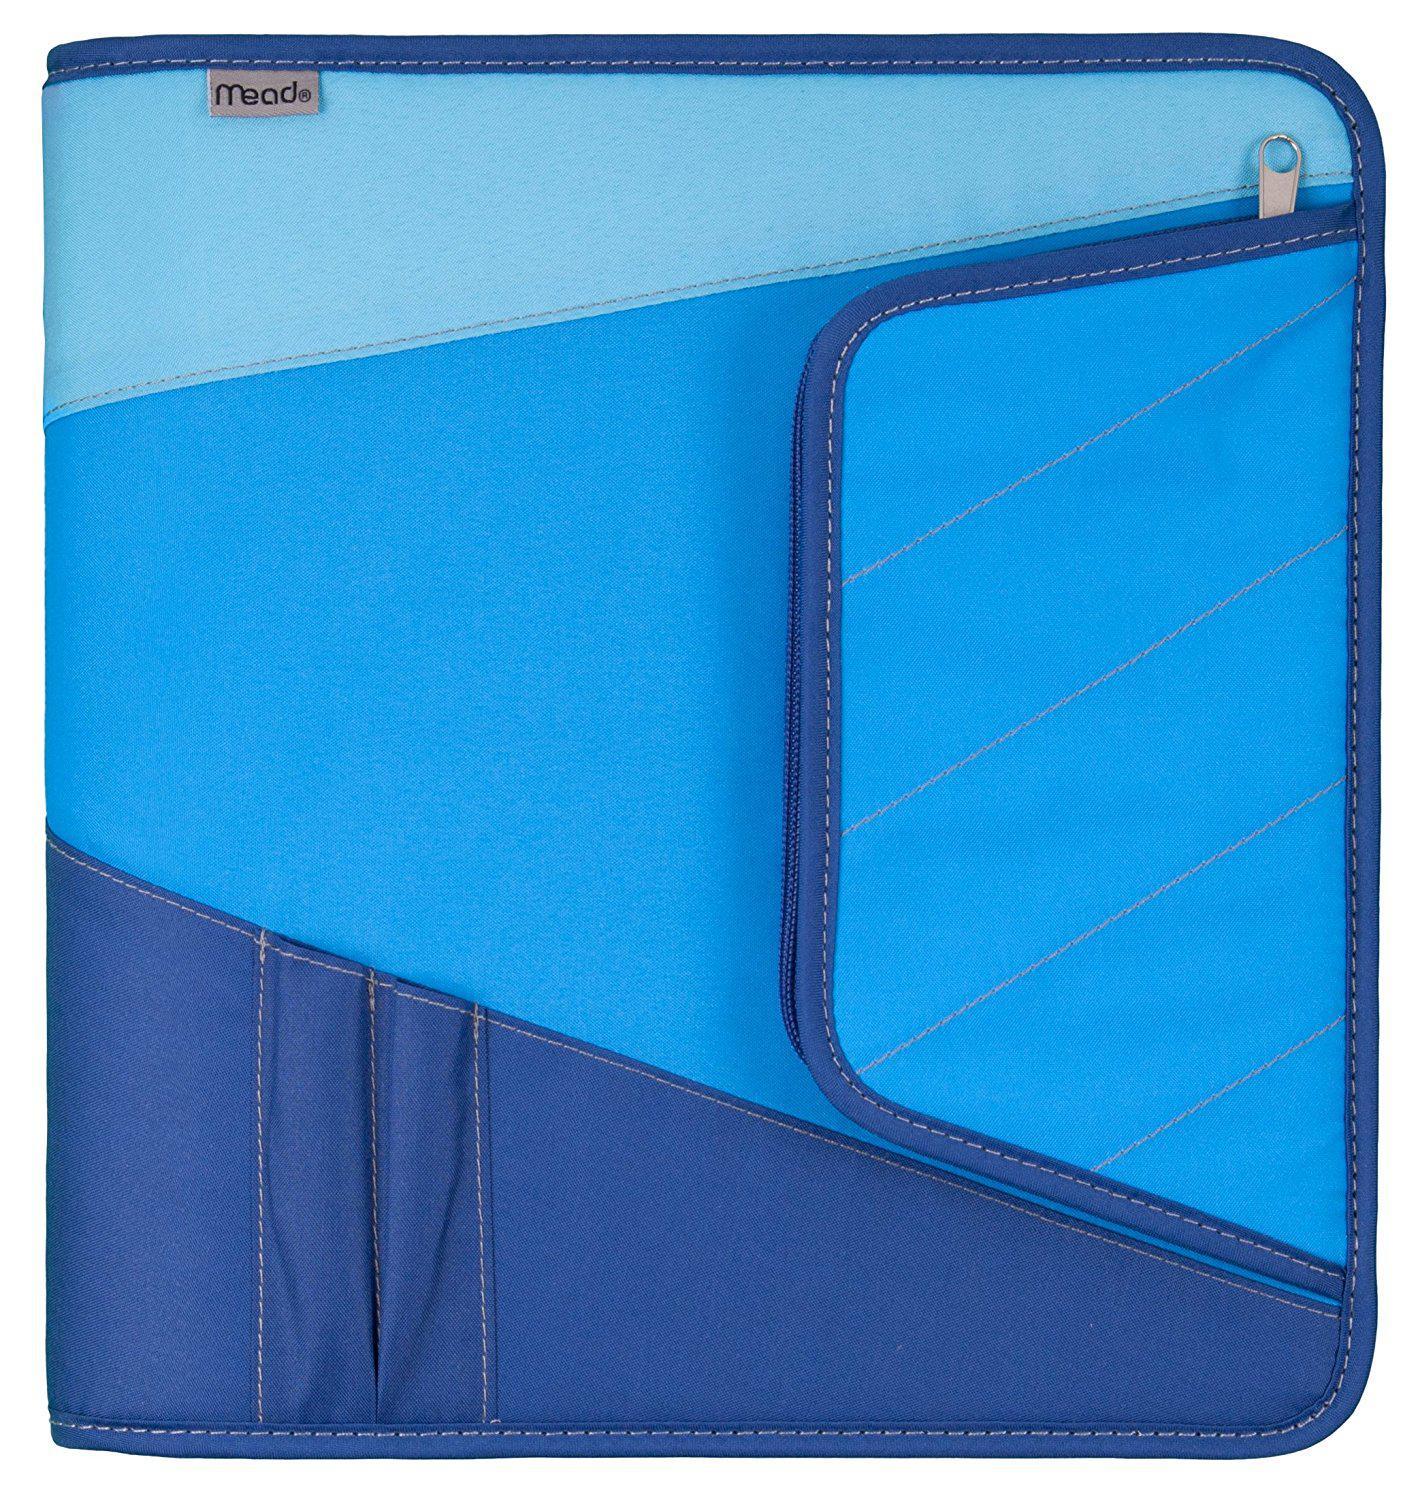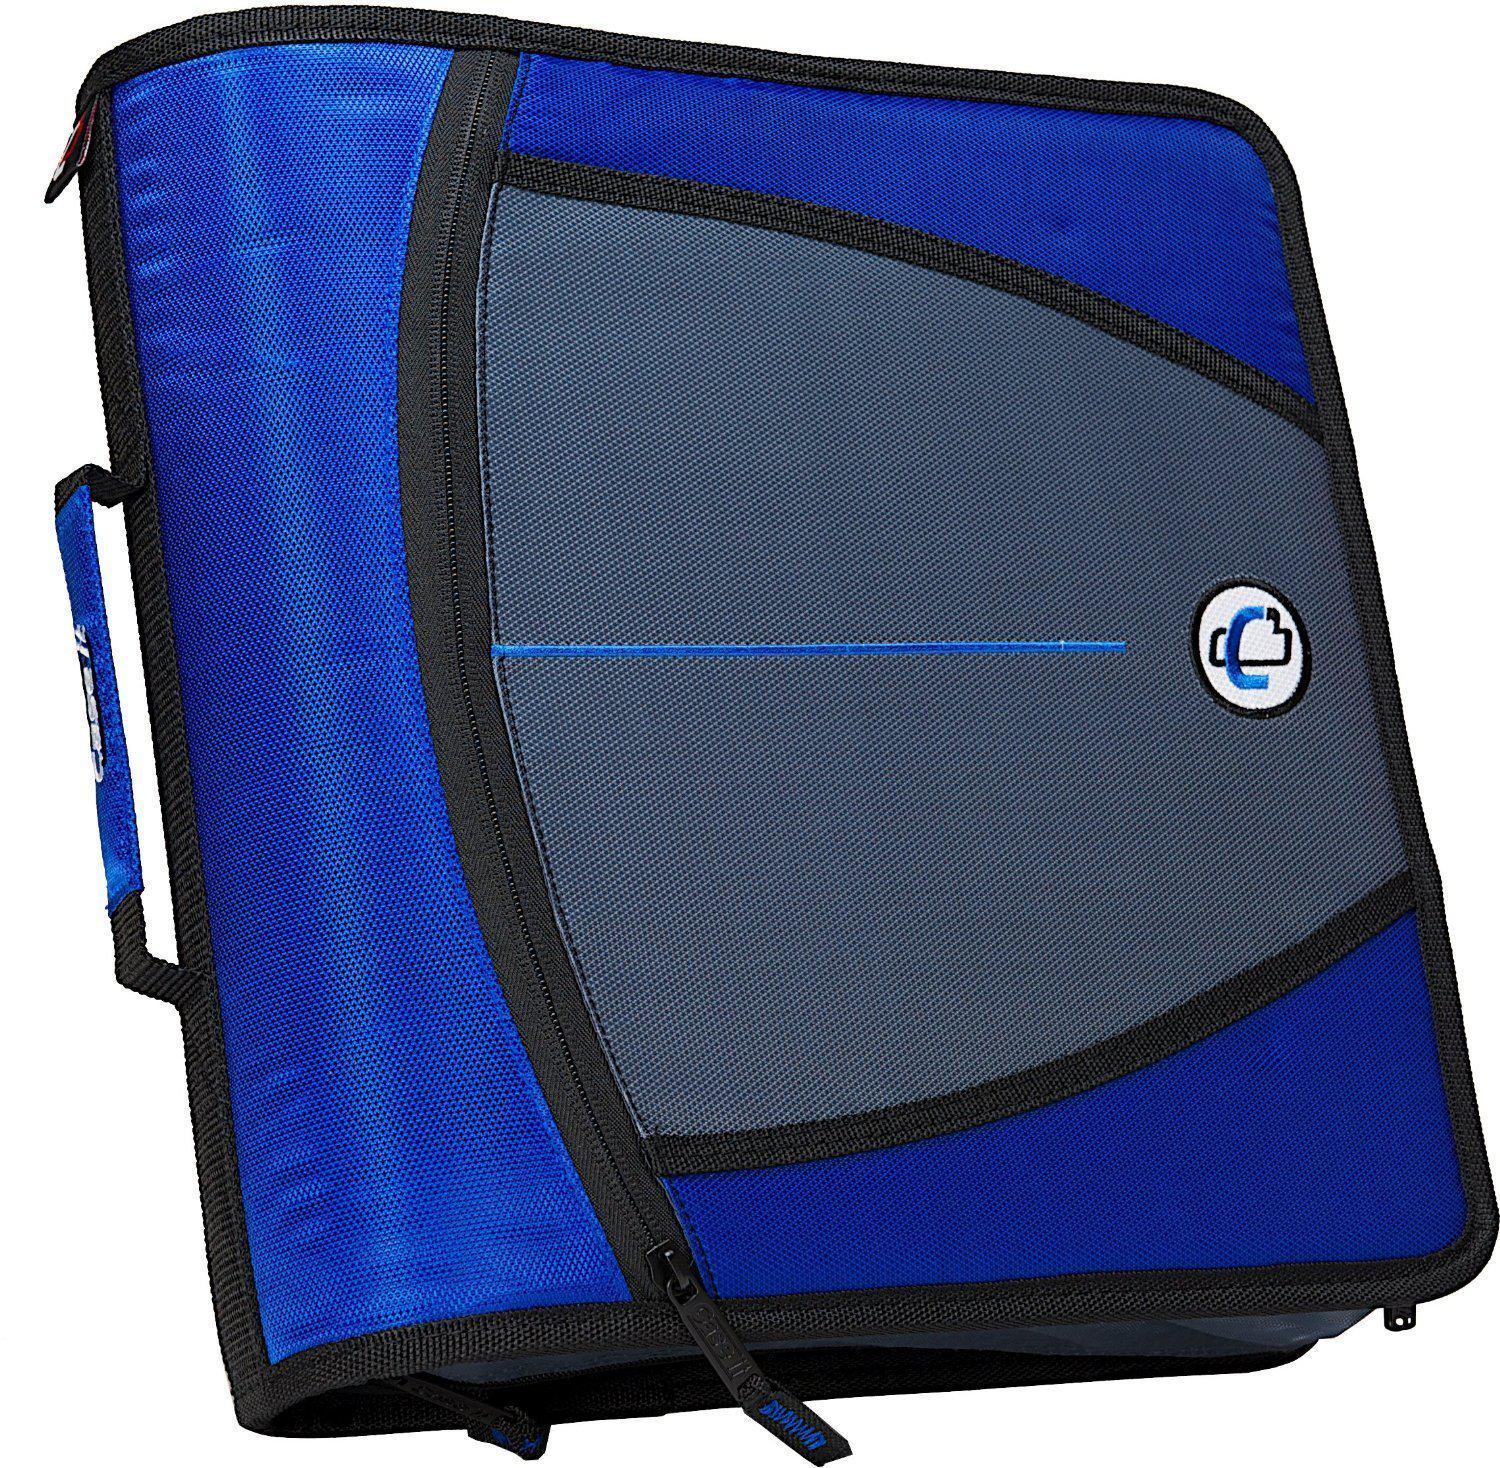The first image is the image on the left, the second image is the image on the right. For the images displayed, is the sentence "The left image shows one blue-toned binder." factually correct? Answer yes or no. Yes. 